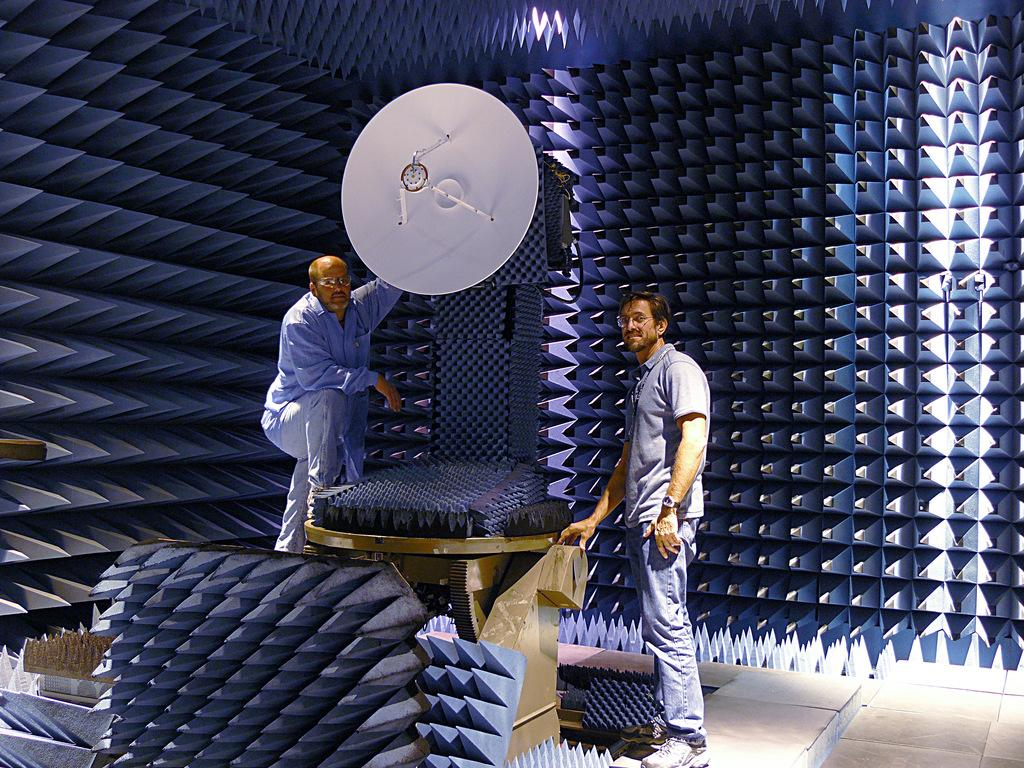How many men wearing spectacles can be seen in the image? There are two men wearing spectacles in the image. What is the position of one of the men in the image? There is a man standing on the floor in the image. What is the facial expression of the man? The man is smiling. What type of structure is visible in the image? There is an antenna in the image. What type of objects with sharp edges can be seen in the image? There are sharp edge objects in the image. How many apples are being held by the men in the image? There are no apples present in the image. Why is the man crying in the image? The man is not crying in the image; he is smiling. 